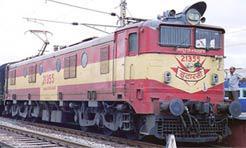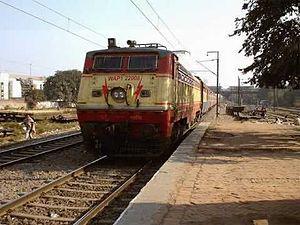The first image is the image on the left, the second image is the image on the right. For the images shown, is this caption "A red train with a yellowish stripe running its length is angled facing rightward." true? Answer yes or no. Yes. The first image is the image on the left, the second image is the image on the right. Given the left and right images, does the statement "There are two trains going in the same direction, none of which are red." hold true? Answer yes or no. No. 